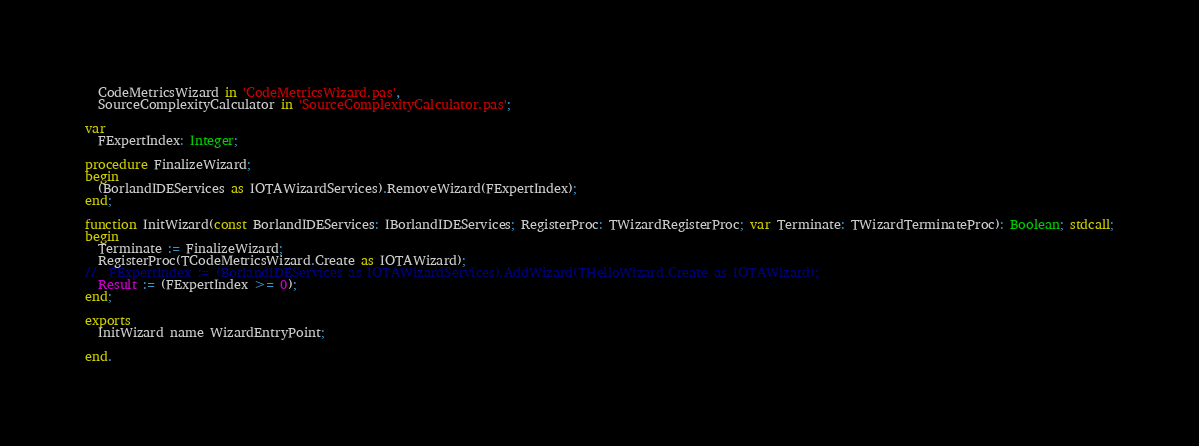<code> <loc_0><loc_0><loc_500><loc_500><_Pascal_>  CodeMetricsWizard in 'CodeMetricsWizard.pas',
  SourceComplexityCalculator in 'SourceComplexityCalculator.pas';

var
  FExpertIndex: Integer;

procedure FinalizeWizard;
begin
  (BorlandIDEServices as IOTAWizardServices).RemoveWizard(FExpertIndex);
end;

function InitWizard(const BorlandIDEServices: IBorlandIDEServices; RegisterProc: TWizardRegisterProc; var Terminate: TWizardTerminateProc): Boolean; stdcall;
begin
  Terminate := FinalizeWizard;
  RegisterProc(TCodeMetricsWizard.Create as IOTAWizard);
//  FExpertIndex := (BorlandIDEServices as IOTAWizardServices).AddWizard(THelloWizard.Create as IOTAWizard);
  Result := (FExpertIndex >= 0);
end;

exports
  InitWizard name WizardEntryPoint;

end.
</code> 